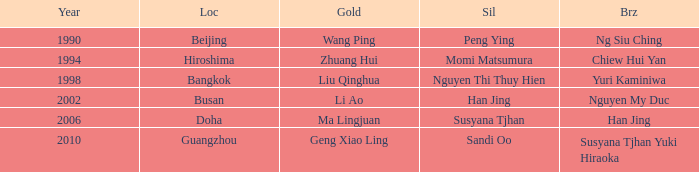What Silver has the Location of Guangzhou? Sandi Oo. 